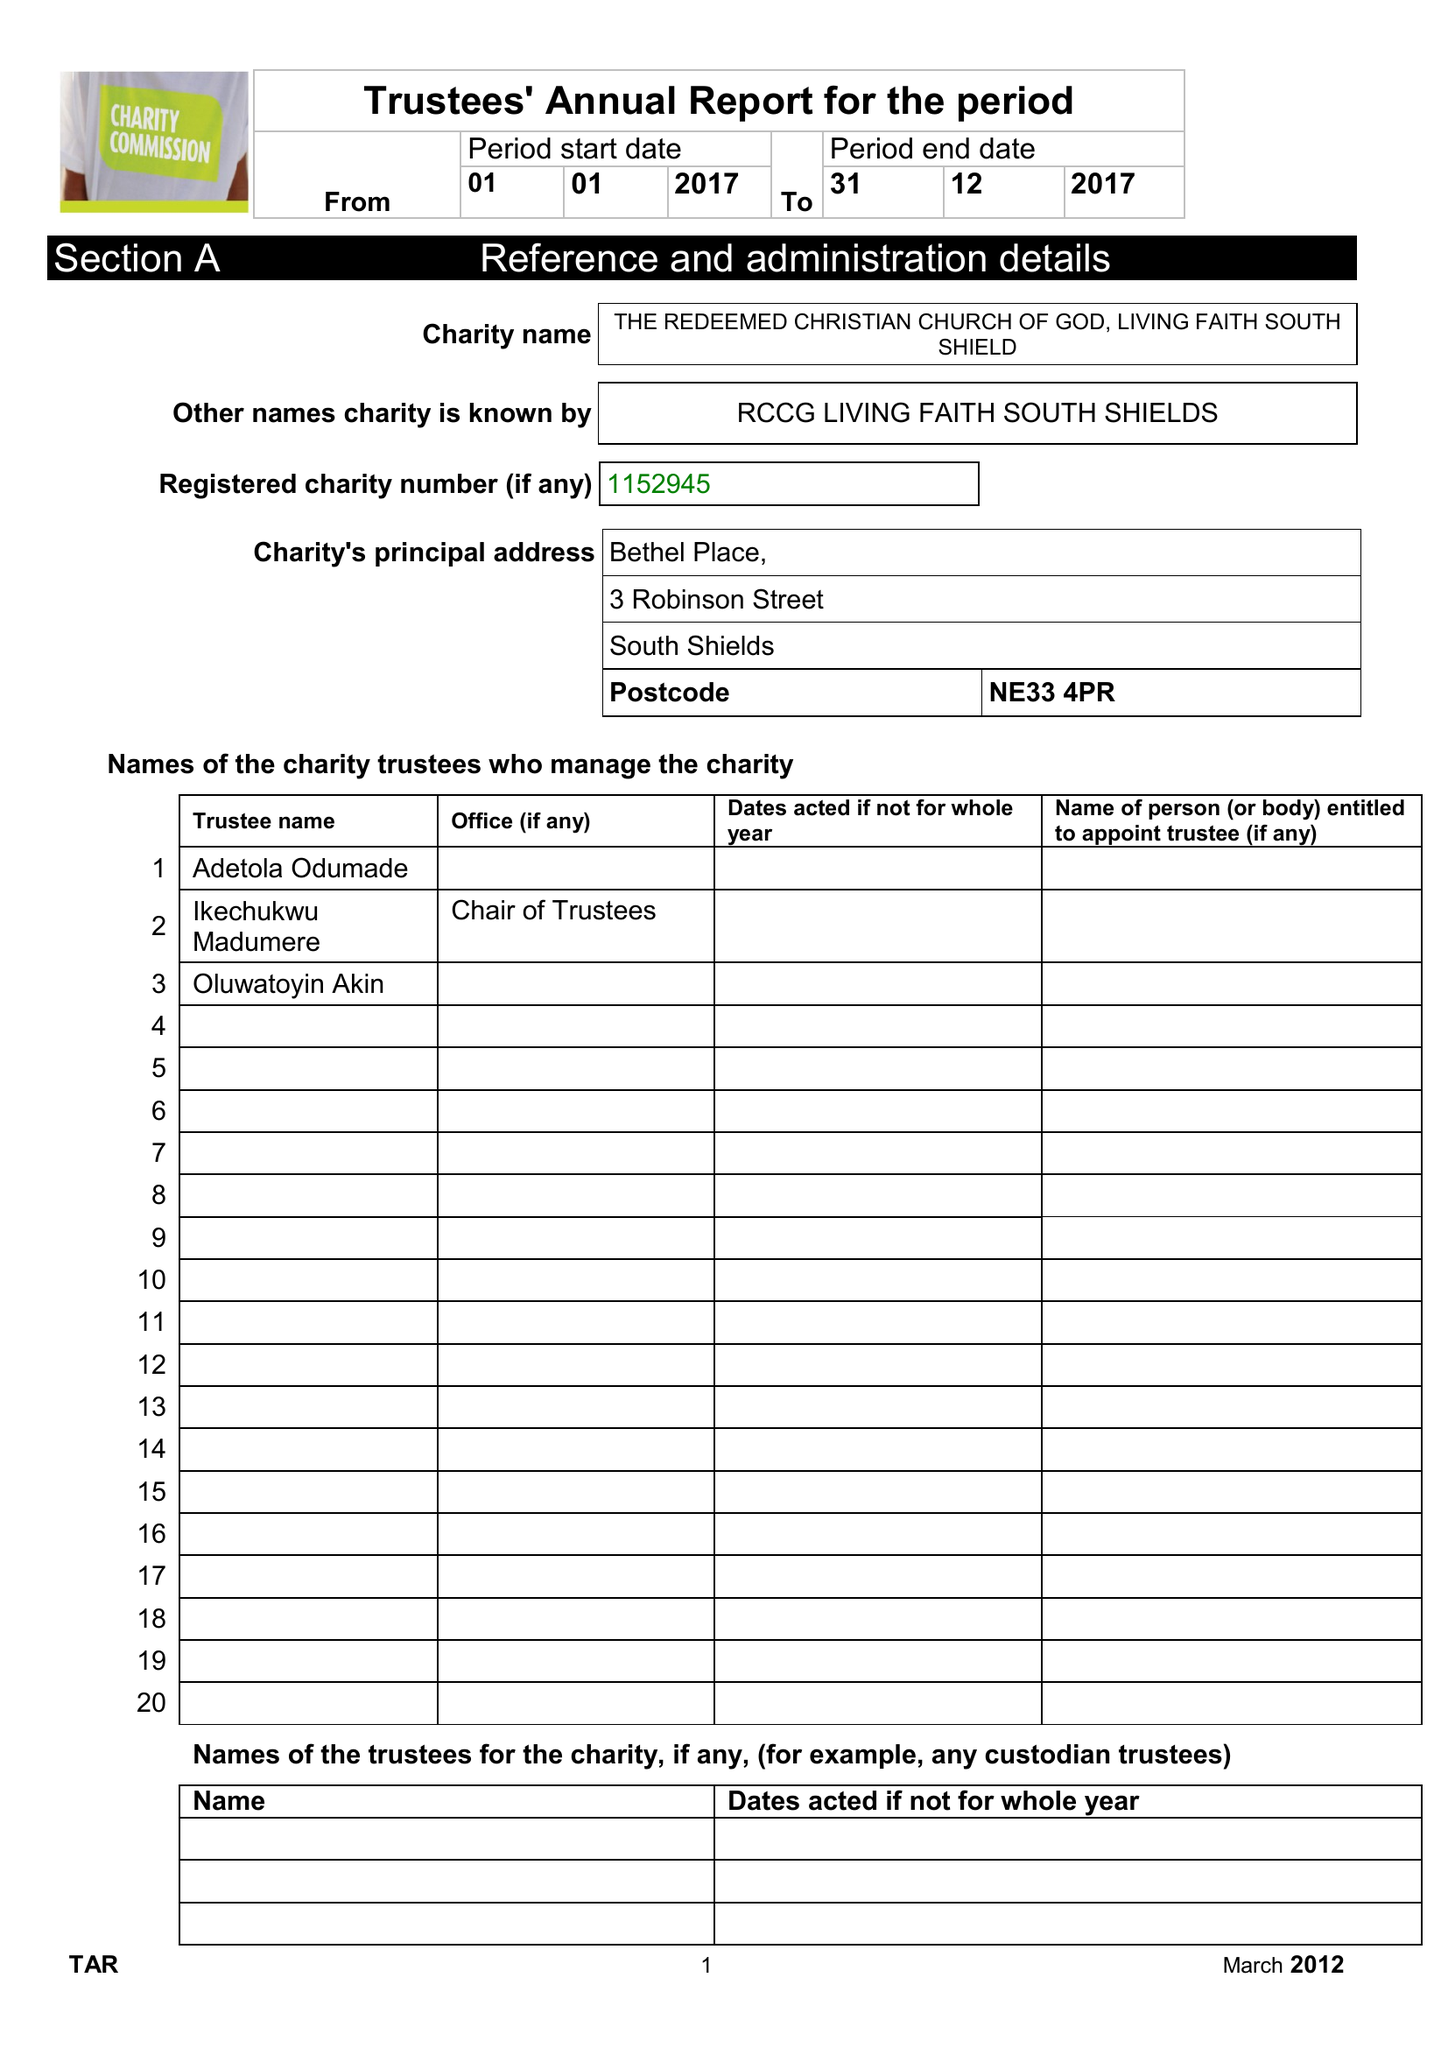What is the value for the report_date?
Answer the question using a single word or phrase. 2017-12-31 